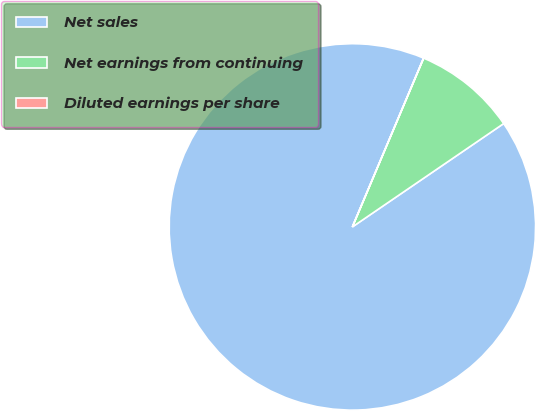Convert chart to OTSL. <chart><loc_0><loc_0><loc_500><loc_500><pie_chart><fcel>Net sales<fcel>Net earnings from continuing<fcel>Diluted earnings per share<nl><fcel>90.89%<fcel>9.1%<fcel>0.01%<nl></chart> 